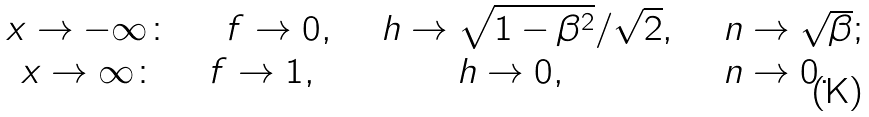<formula> <loc_0><loc_0><loc_500><loc_500>\begin{array} { c c c c } x \rightarrow - \infty \colon & \quad f \rightarrow 0 , & \quad h \rightarrow \sqrt { 1 - \beta ^ { 2 } } / \sqrt { 2 } , & \quad n \rightarrow \sqrt { \beta } ; \\ x \rightarrow \infty \colon & f \rightarrow 1 , & h \rightarrow 0 , & n \rightarrow 0 . \end{array}</formula> 